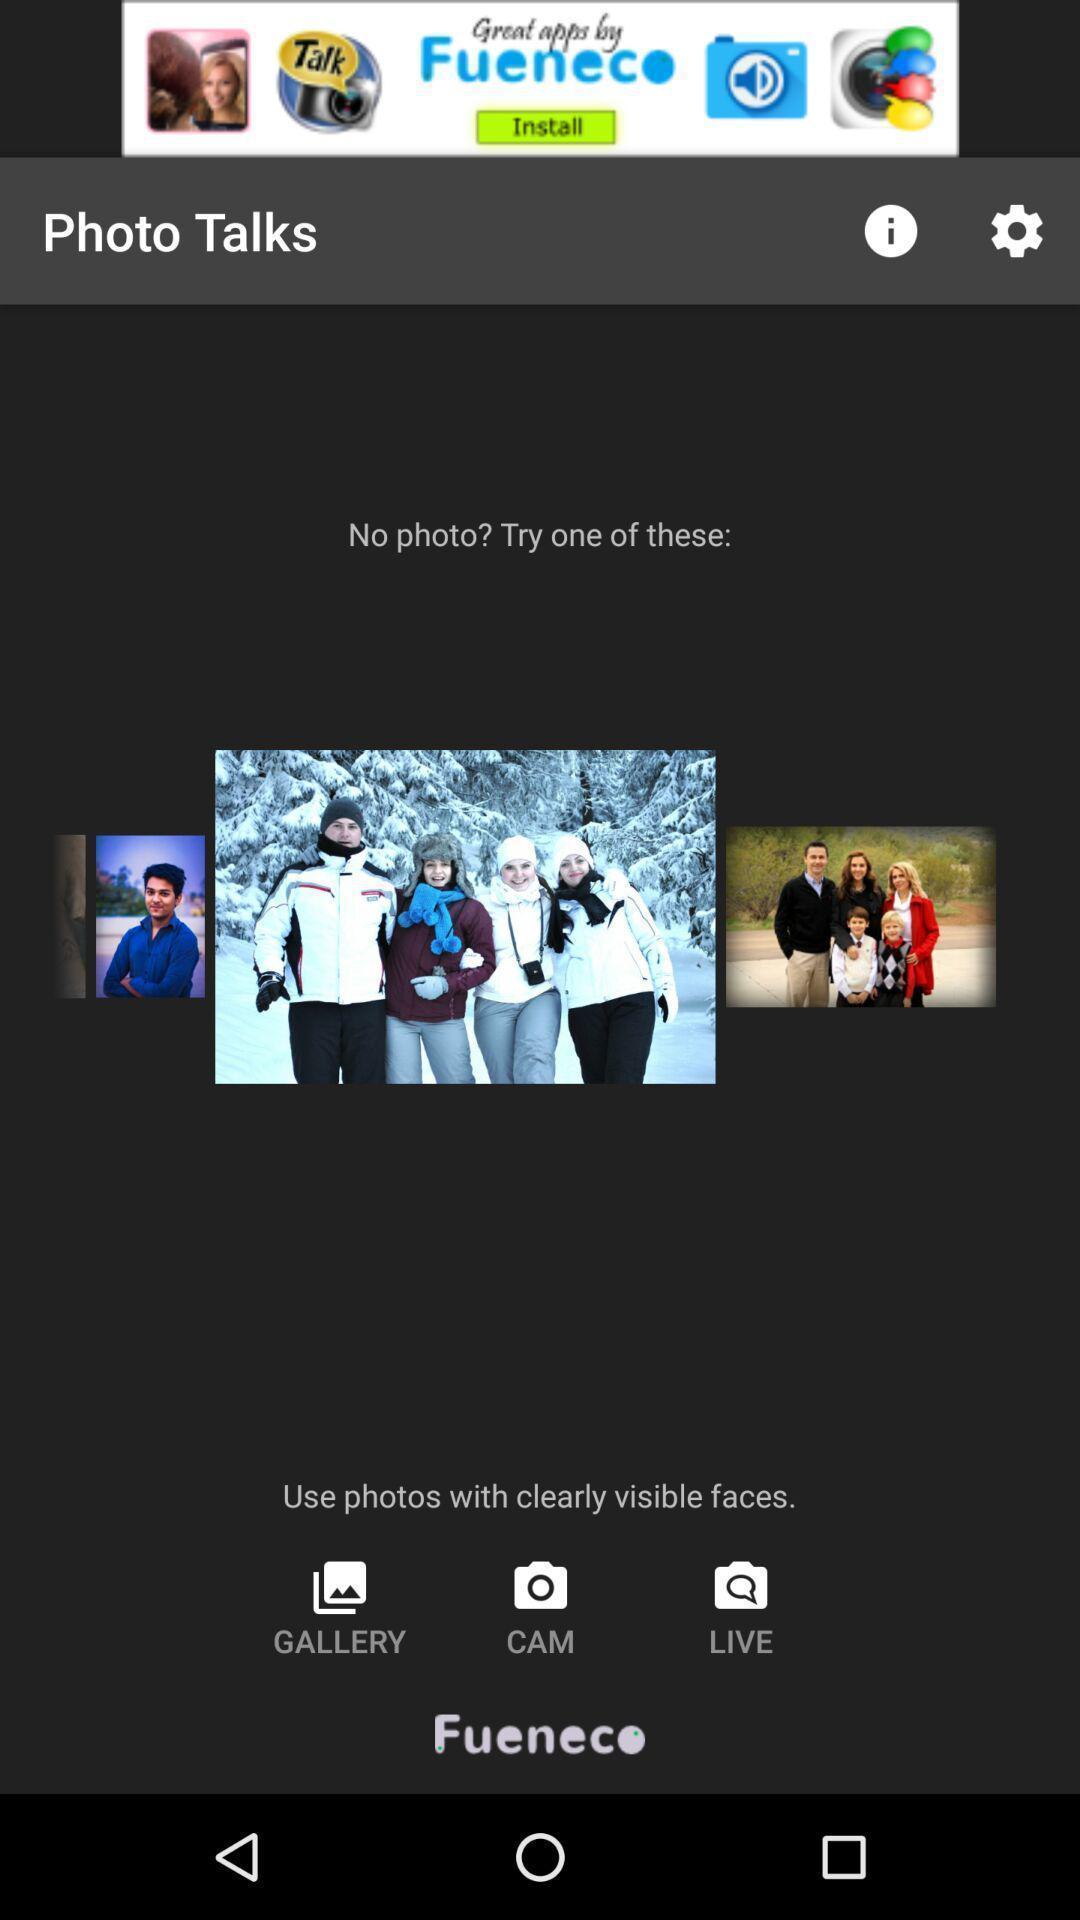Give me a narrative description of this picture. Page showing different options like gallery. 